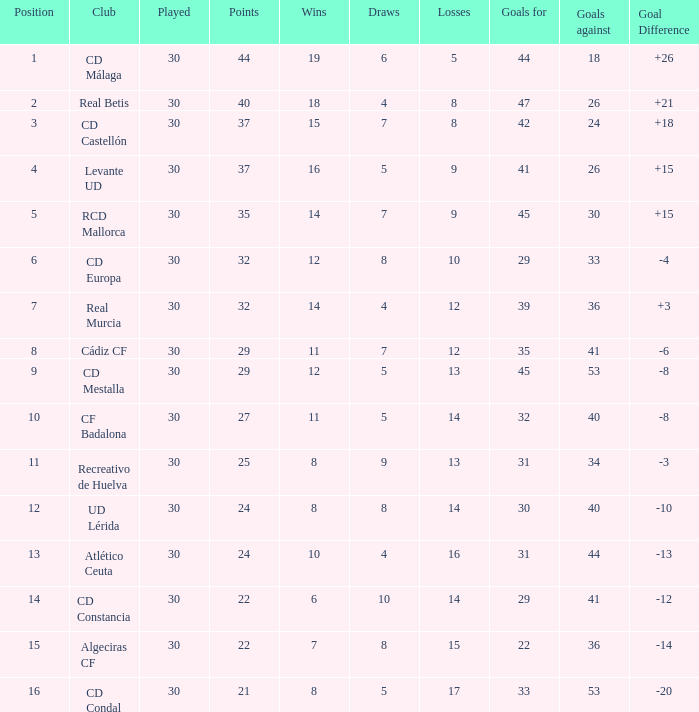When the goal difference is greater than 26, what are the losses? None. 